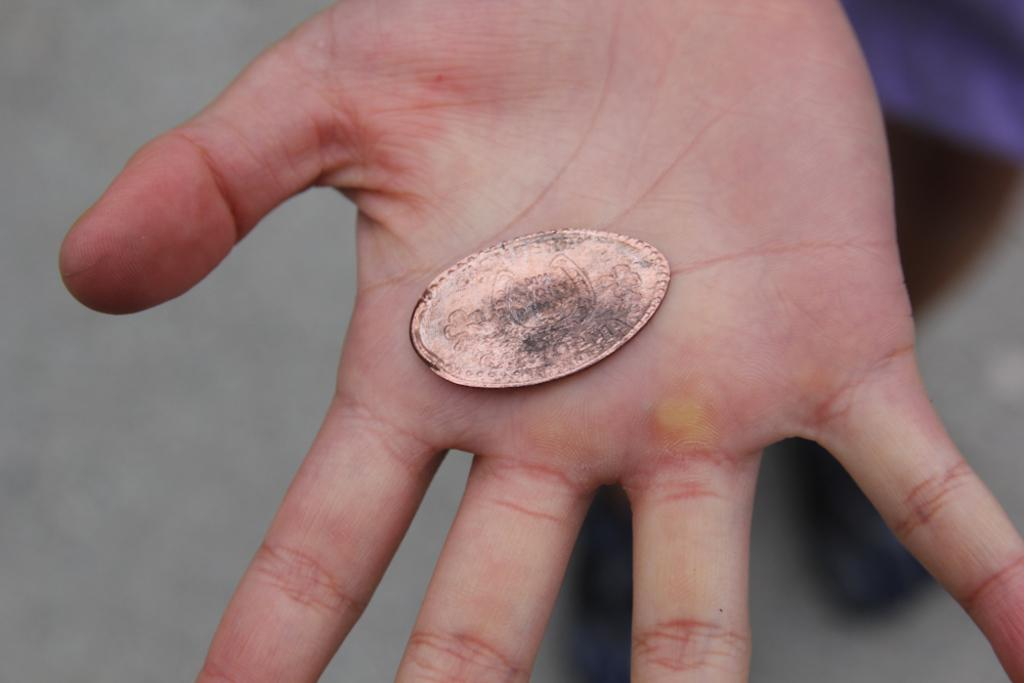What can be seen in the person's hand in the image? There is a coin in the person's hand. Can you describe the person's hand in the image? The person's hand is holding a coin. What day of the week is depicted in the image? There is no indication of a specific day of the week in the image. What type of watch is visible on the person's wrist in the image? There is no watch visible on the person's wrist in the image. 